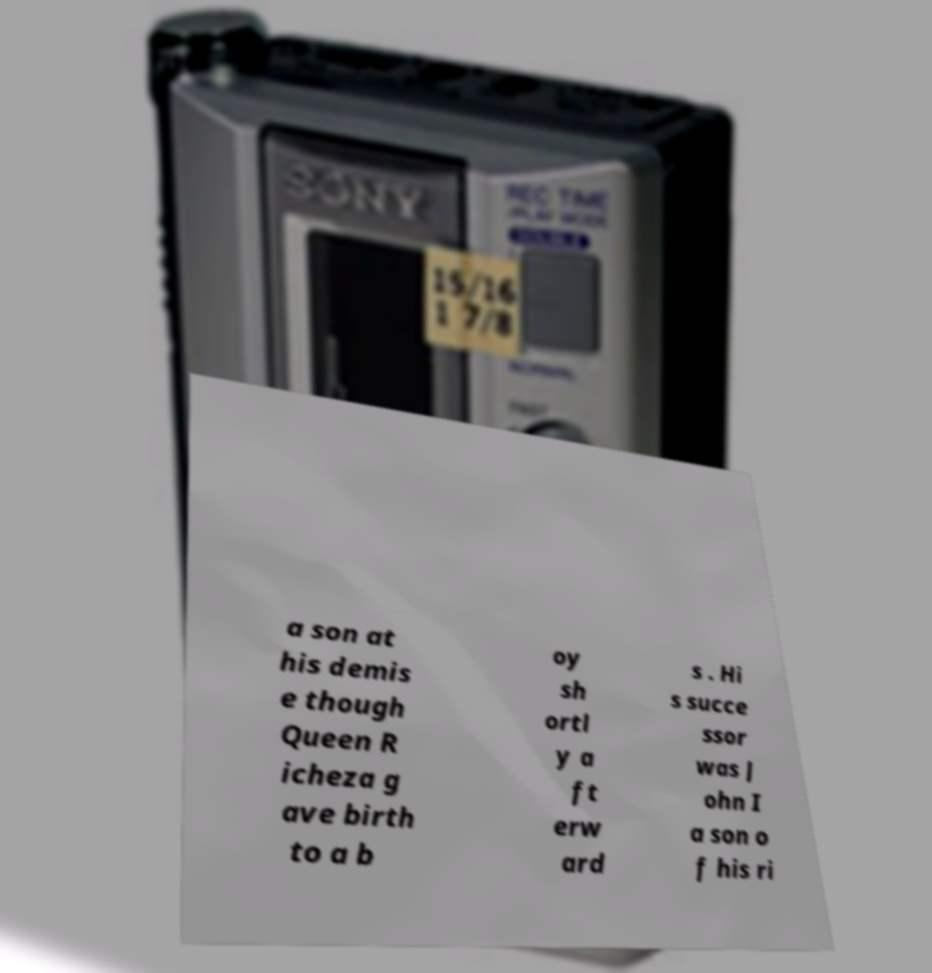Can you read and provide the text displayed in the image?This photo seems to have some interesting text. Can you extract and type it out for me? a son at his demis e though Queen R icheza g ave birth to a b oy sh ortl y a ft erw ard s . Hi s succe ssor was J ohn I a son o f his ri 